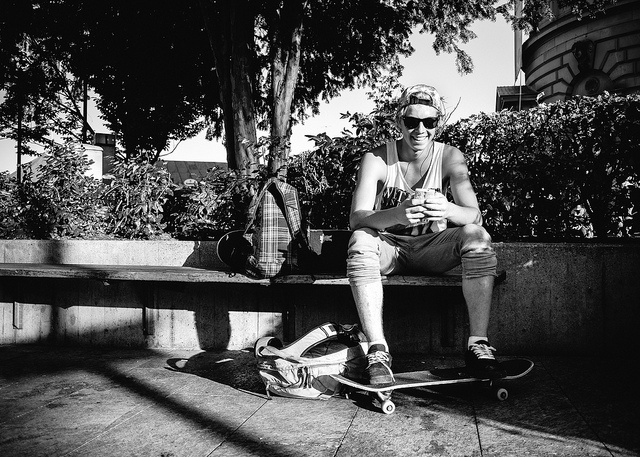Describe the objects in this image and their specific colors. I can see people in black, lightgray, gray, and darkgray tones, bench in black, darkgray, gray, and lightgray tones, backpack in black, lightgray, gray, and darkgray tones, backpack in black, gray, darkgray, and lightgray tones, and bench in black, gray, and lightgray tones in this image. 